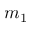Convert formula to latex. <formula><loc_0><loc_0><loc_500><loc_500>m _ { 1 }</formula> 